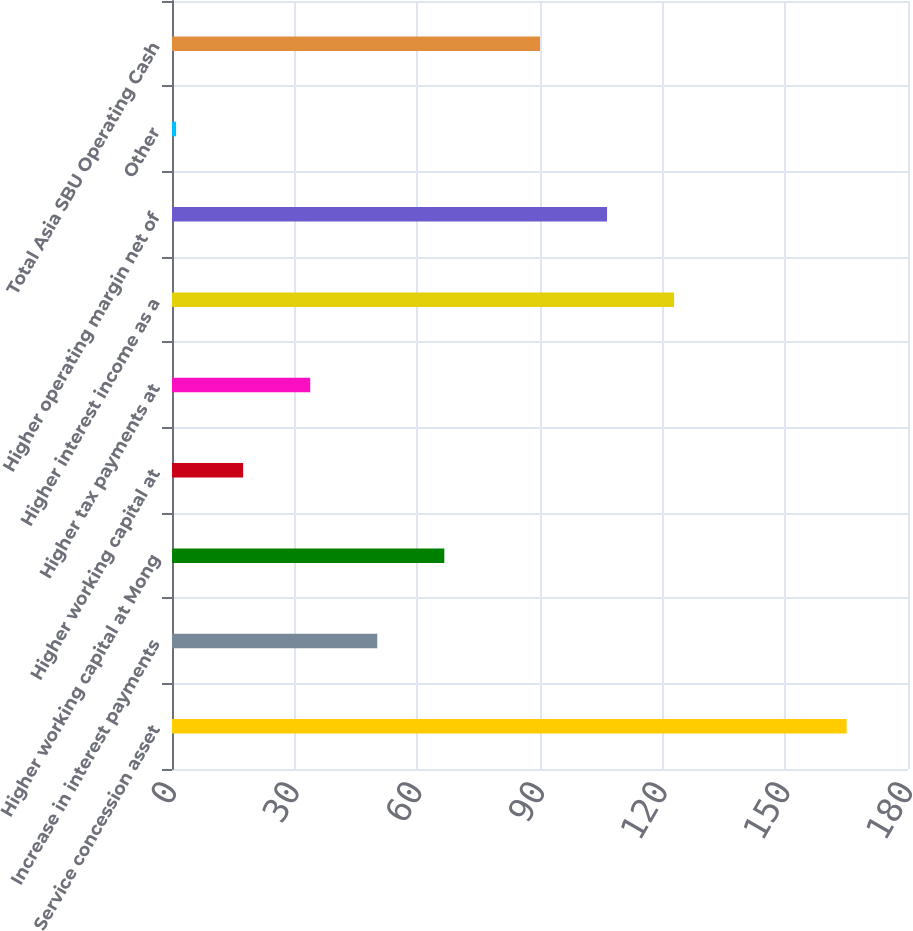Convert chart. <chart><loc_0><loc_0><loc_500><loc_500><bar_chart><fcel>Service concession asset<fcel>Increase in interest payments<fcel>Higher working capital at Mong<fcel>Higher working capital at<fcel>Higher tax payments at<fcel>Higher interest income as a<fcel>Higher operating margin net of<fcel>Other<fcel>Total Asia SBU Operating Cash<nl><fcel>165<fcel>50.2<fcel>66.6<fcel>17.4<fcel>33.8<fcel>122.8<fcel>106.4<fcel>1<fcel>90<nl></chart> 